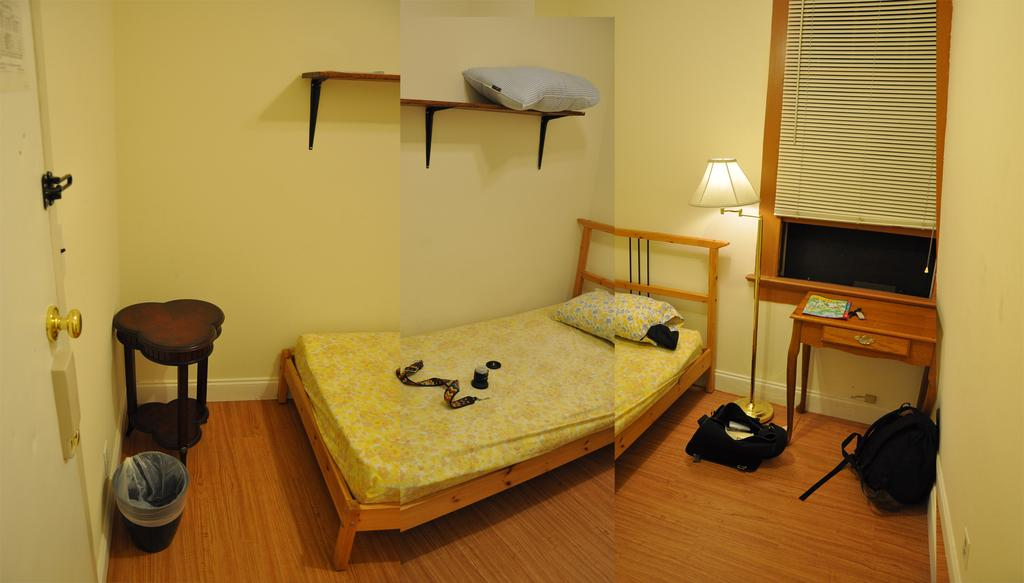What type of artwork is the image? The image is a collage of two images. What type of furniture is present in the image? There is a bed, a pillow, and tables in the image. What type of container is in the image? There is a dustbin in the image. What type of structure is attached to the wall in the image? There are stands attached to the wall in the image. What type of objects can be seen on the floor in the image? There are objects on the floor in the image. What type of lunch is being served on the bed in the image? There is no lunch being served in the image; it is a collage of two images with furniture and other objects. What type of mark can be seen on the pillow in the image? There is no mark visible on the pillow in the image. 